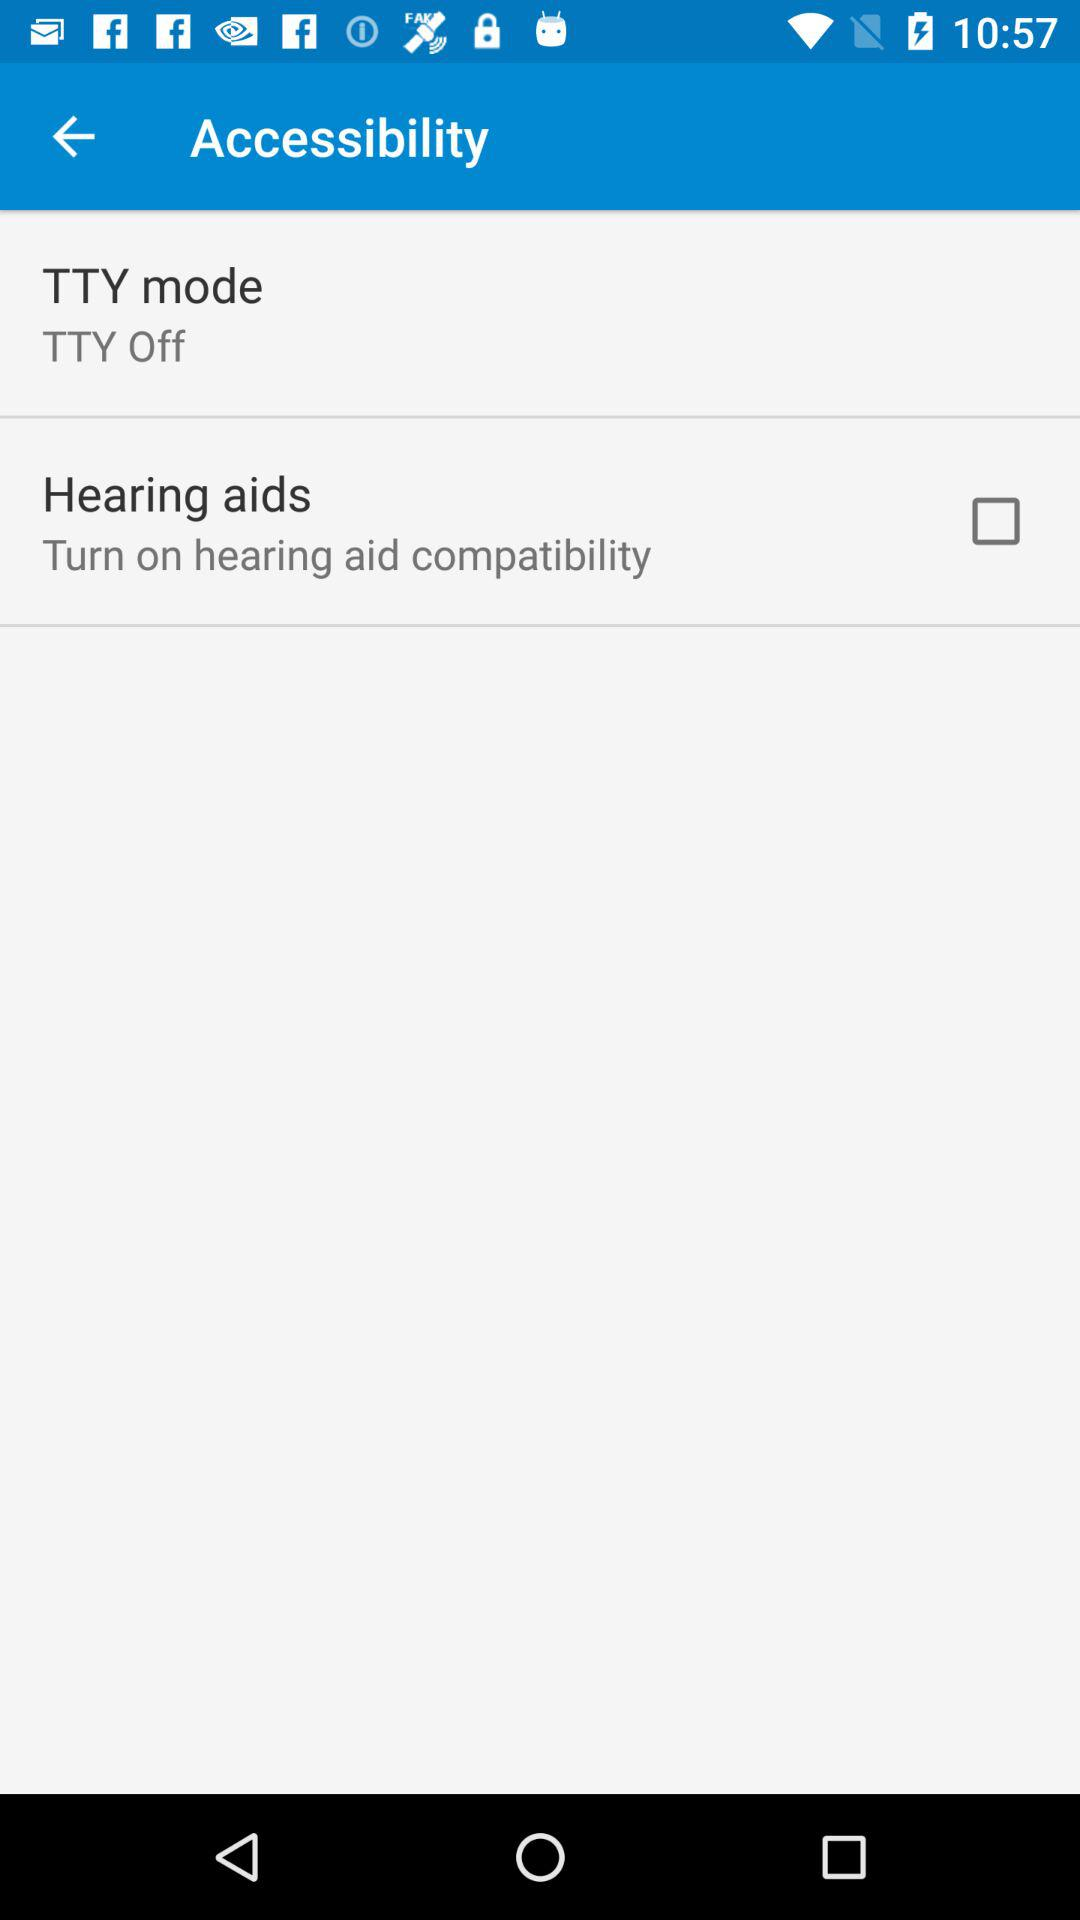What is the "TTY mode" setting? The "TTY mode" setting is "TTY Off". 